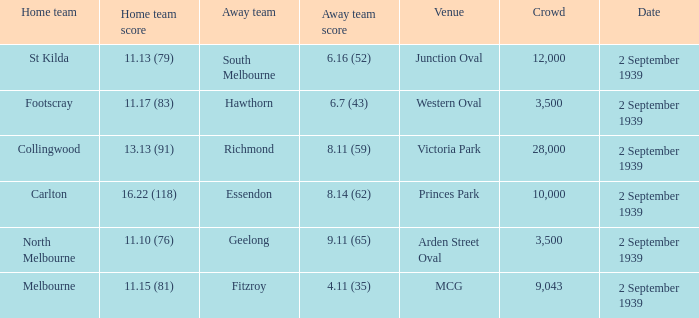What was the crowd size of the match featuring Hawthorn as the Away team? 3500.0. 